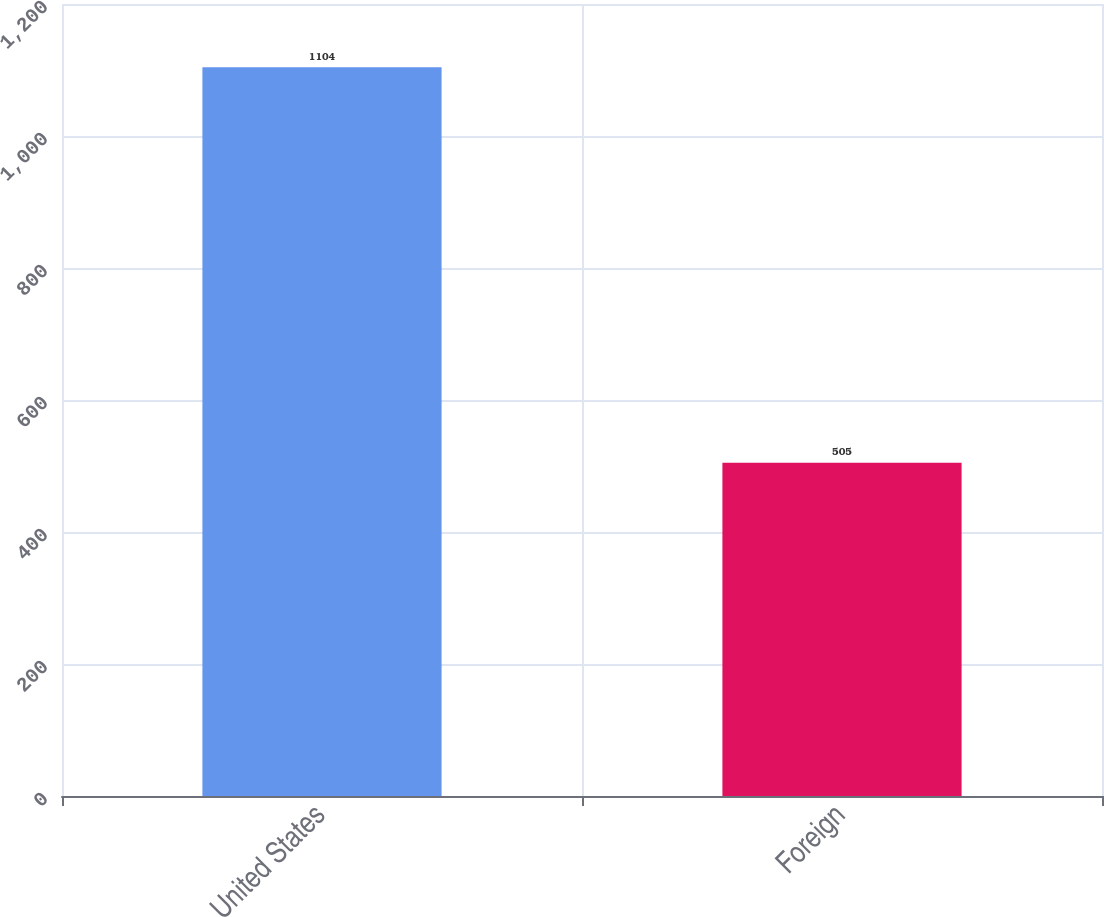Convert chart to OTSL. <chart><loc_0><loc_0><loc_500><loc_500><bar_chart><fcel>United States<fcel>Foreign<nl><fcel>1104<fcel>505<nl></chart> 